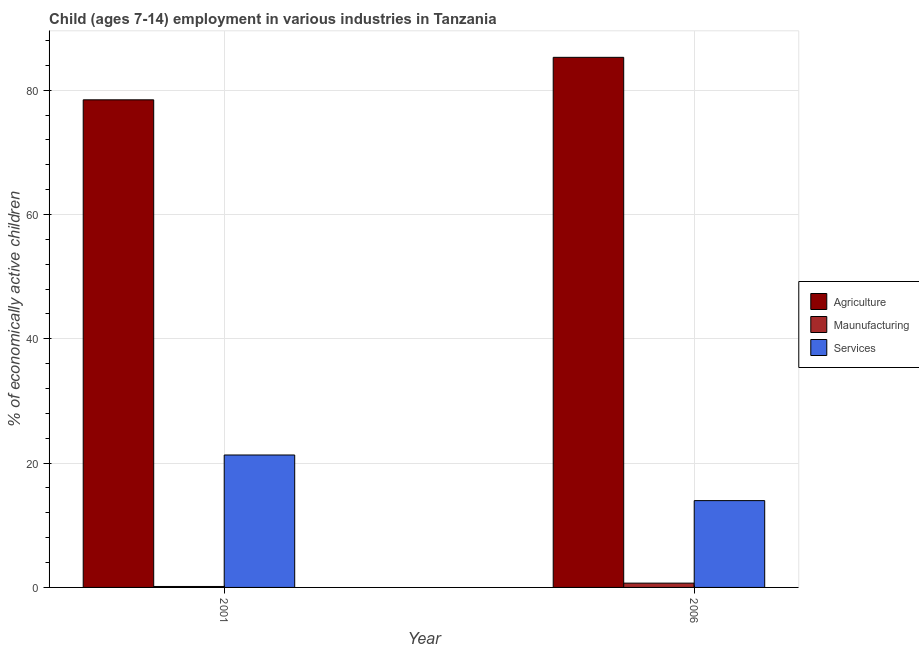Are the number of bars on each tick of the X-axis equal?
Provide a succinct answer. Yes. How many bars are there on the 2nd tick from the left?
Ensure brevity in your answer.  3. How many bars are there on the 2nd tick from the right?
Your answer should be compact. 3. In how many cases, is the number of bars for a given year not equal to the number of legend labels?
Provide a short and direct response. 0. What is the percentage of economically active children in agriculture in 2006?
Give a very brief answer. 85.3. Across all years, what is the maximum percentage of economically active children in agriculture?
Provide a succinct answer. 85.3. Across all years, what is the minimum percentage of economically active children in services?
Ensure brevity in your answer.  13.97. What is the total percentage of economically active children in agriculture in the graph?
Keep it short and to the point. 163.76. What is the difference between the percentage of economically active children in manufacturing in 2001 and that in 2006?
Offer a very short reply. -0.54. What is the difference between the percentage of economically active children in services in 2006 and the percentage of economically active children in manufacturing in 2001?
Offer a very short reply. -7.34. What is the average percentage of economically active children in agriculture per year?
Give a very brief answer. 81.88. What is the ratio of the percentage of economically active children in services in 2001 to that in 2006?
Ensure brevity in your answer.  1.53. In how many years, is the percentage of economically active children in manufacturing greater than the average percentage of economically active children in manufacturing taken over all years?
Keep it short and to the point. 1. What does the 1st bar from the left in 2001 represents?
Your answer should be very brief. Agriculture. What does the 1st bar from the right in 2001 represents?
Provide a succinct answer. Services. Is it the case that in every year, the sum of the percentage of economically active children in agriculture and percentage of economically active children in manufacturing is greater than the percentage of economically active children in services?
Make the answer very short. Yes. How many bars are there?
Provide a succinct answer. 6. How many years are there in the graph?
Provide a short and direct response. 2. What is the difference between two consecutive major ticks on the Y-axis?
Keep it short and to the point. 20. Are the values on the major ticks of Y-axis written in scientific E-notation?
Ensure brevity in your answer.  No. Does the graph contain any zero values?
Offer a very short reply. No. What is the title of the graph?
Ensure brevity in your answer.  Child (ages 7-14) employment in various industries in Tanzania. What is the label or title of the Y-axis?
Keep it short and to the point. % of economically active children. What is the % of economically active children of Agriculture in 2001?
Your answer should be very brief. 78.46. What is the % of economically active children in Maunufacturing in 2001?
Your answer should be very brief. 0.15. What is the % of economically active children in Services in 2001?
Offer a terse response. 21.31. What is the % of economically active children in Agriculture in 2006?
Provide a short and direct response. 85.3. What is the % of economically active children of Maunufacturing in 2006?
Make the answer very short. 0.69. What is the % of economically active children in Services in 2006?
Provide a succinct answer. 13.97. Across all years, what is the maximum % of economically active children in Agriculture?
Provide a short and direct response. 85.3. Across all years, what is the maximum % of economically active children of Maunufacturing?
Ensure brevity in your answer.  0.69. Across all years, what is the maximum % of economically active children in Services?
Make the answer very short. 21.31. Across all years, what is the minimum % of economically active children in Agriculture?
Provide a short and direct response. 78.46. Across all years, what is the minimum % of economically active children of Maunufacturing?
Offer a terse response. 0.15. Across all years, what is the minimum % of economically active children of Services?
Your answer should be very brief. 13.97. What is the total % of economically active children of Agriculture in the graph?
Your answer should be compact. 163.76. What is the total % of economically active children of Maunufacturing in the graph?
Offer a terse response. 0.84. What is the total % of economically active children of Services in the graph?
Provide a short and direct response. 35.28. What is the difference between the % of economically active children in Agriculture in 2001 and that in 2006?
Give a very brief answer. -6.84. What is the difference between the % of economically active children in Maunufacturing in 2001 and that in 2006?
Give a very brief answer. -0.54. What is the difference between the % of economically active children of Services in 2001 and that in 2006?
Offer a terse response. 7.34. What is the difference between the % of economically active children of Agriculture in 2001 and the % of economically active children of Maunufacturing in 2006?
Give a very brief answer. 77.77. What is the difference between the % of economically active children in Agriculture in 2001 and the % of economically active children in Services in 2006?
Provide a succinct answer. 64.49. What is the difference between the % of economically active children in Maunufacturing in 2001 and the % of economically active children in Services in 2006?
Provide a succinct answer. -13.82. What is the average % of economically active children in Agriculture per year?
Provide a succinct answer. 81.88. What is the average % of economically active children in Maunufacturing per year?
Make the answer very short. 0.42. What is the average % of economically active children in Services per year?
Give a very brief answer. 17.64. In the year 2001, what is the difference between the % of economically active children of Agriculture and % of economically active children of Maunufacturing?
Provide a succinct answer. 78.31. In the year 2001, what is the difference between the % of economically active children of Agriculture and % of economically active children of Services?
Provide a succinct answer. 57.15. In the year 2001, what is the difference between the % of economically active children in Maunufacturing and % of economically active children in Services?
Your response must be concise. -21.16. In the year 2006, what is the difference between the % of economically active children in Agriculture and % of economically active children in Maunufacturing?
Your answer should be compact. 84.61. In the year 2006, what is the difference between the % of economically active children in Agriculture and % of economically active children in Services?
Offer a terse response. 71.33. In the year 2006, what is the difference between the % of economically active children of Maunufacturing and % of economically active children of Services?
Your answer should be very brief. -13.28. What is the ratio of the % of economically active children in Agriculture in 2001 to that in 2006?
Ensure brevity in your answer.  0.92. What is the ratio of the % of economically active children of Maunufacturing in 2001 to that in 2006?
Provide a succinct answer. 0.22. What is the ratio of the % of economically active children of Services in 2001 to that in 2006?
Keep it short and to the point. 1.53. What is the difference between the highest and the second highest % of economically active children of Agriculture?
Your answer should be very brief. 6.84. What is the difference between the highest and the second highest % of economically active children in Maunufacturing?
Give a very brief answer. 0.54. What is the difference between the highest and the second highest % of economically active children of Services?
Provide a short and direct response. 7.34. What is the difference between the highest and the lowest % of economically active children in Agriculture?
Provide a succinct answer. 6.84. What is the difference between the highest and the lowest % of economically active children in Maunufacturing?
Give a very brief answer. 0.54. What is the difference between the highest and the lowest % of economically active children of Services?
Make the answer very short. 7.34. 